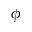<formula> <loc_0><loc_0><loc_500><loc_500>\phi</formula> 